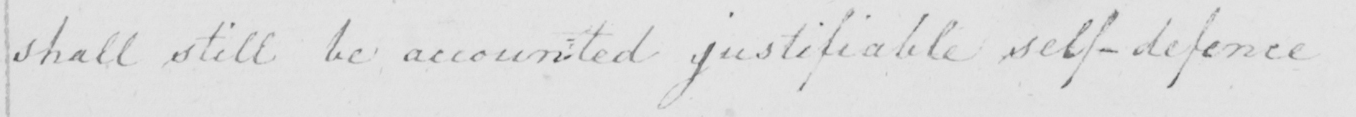What text is written in this handwritten line? shall still be accounted justifiable self-defence 